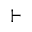<formula> <loc_0><loc_0><loc_500><loc_500>\vdash</formula> 